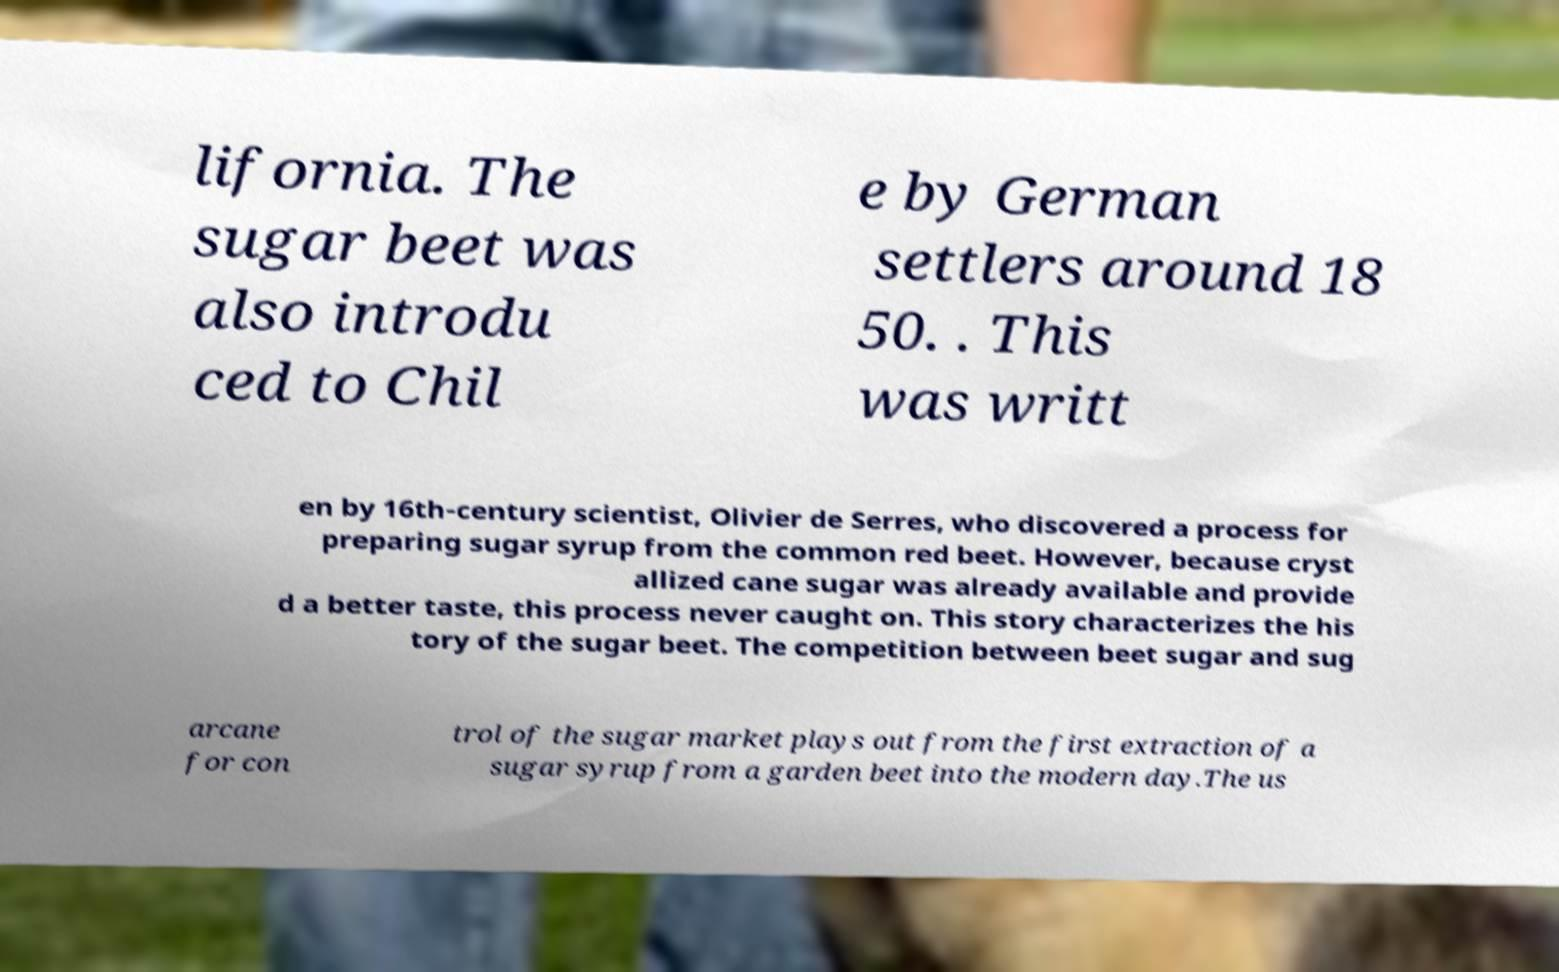What messages or text are displayed in this image? I need them in a readable, typed format. lifornia. The sugar beet was also introdu ced to Chil e by German settlers around 18 50. . This was writt en by 16th-century scientist, Olivier de Serres, who discovered a process for preparing sugar syrup from the common red beet. However, because cryst allized cane sugar was already available and provide d a better taste, this process never caught on. This story characterizes the his tory of the sugar beet. The competition between beet sugar and sug arcane for con trol of the sugar market plays out from the first extraction of a sugar syrup from a garden beet into the modern day.The us 